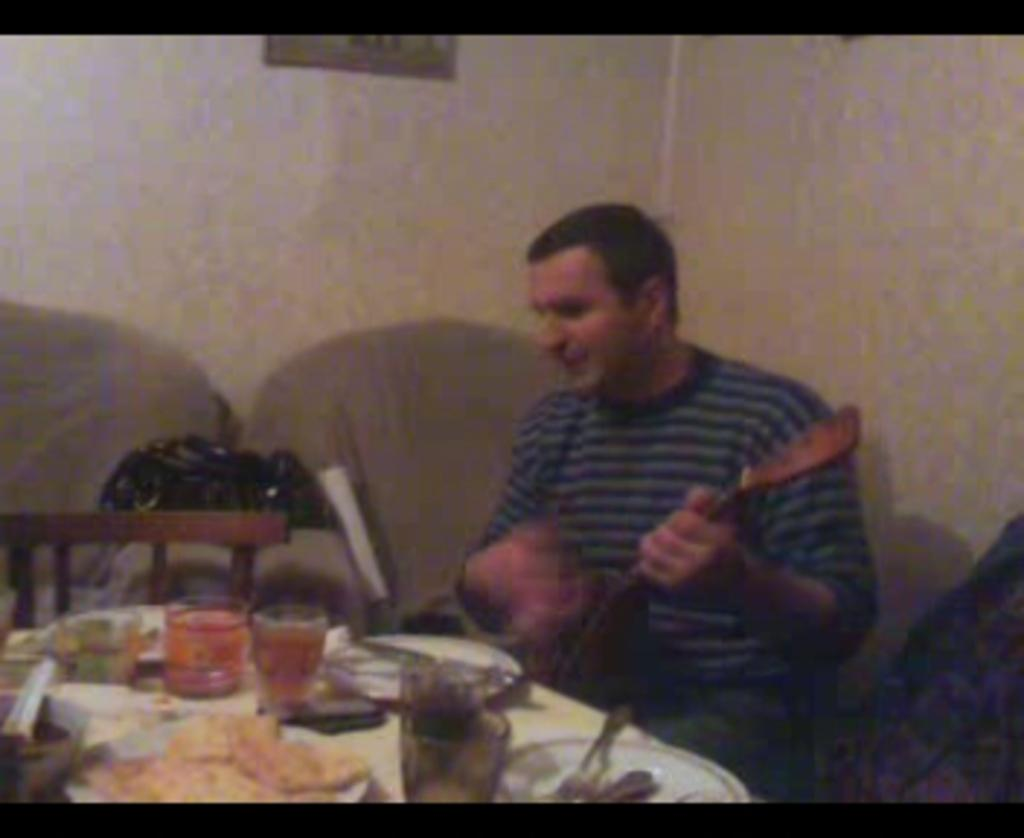What type of furniture is present in the image? There is a table and chairs in the image. What is the person in the image doing? The person is sitting in a chair and playing a guitar. What items can be seen on the table? There are plates, glasses, forks, and spoons on the table. How many cobwebs are hanging from the guitar in the image? There are no cobwebs present in the image. 